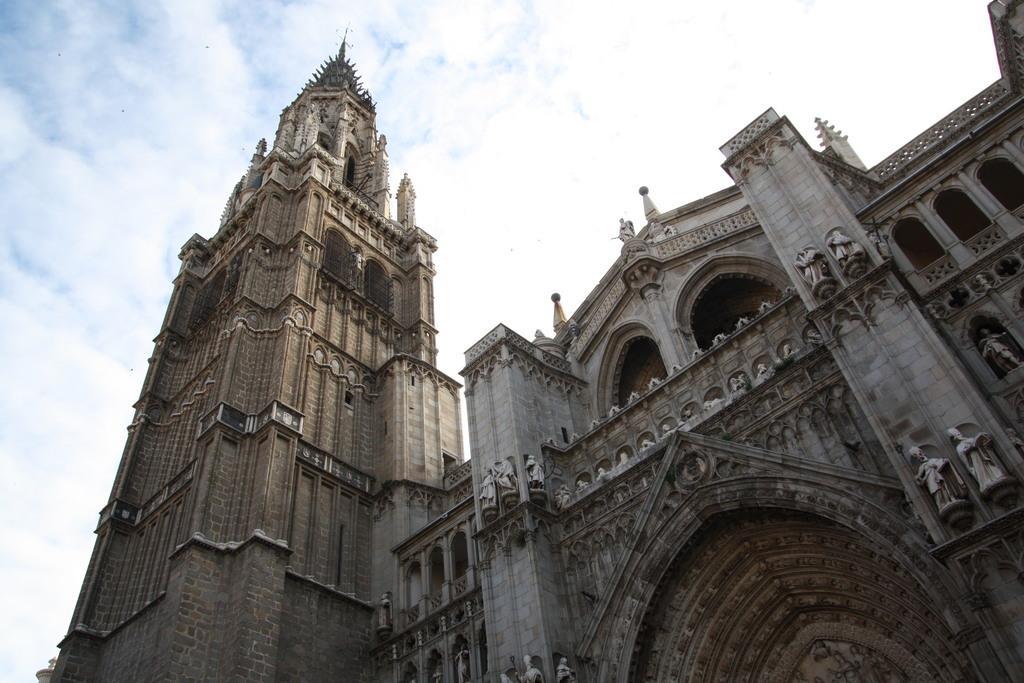Can you describe this image briefly? In this image there is a building, on the building there are some engravings and statues, at the top of the image there are clouds in the sky. 